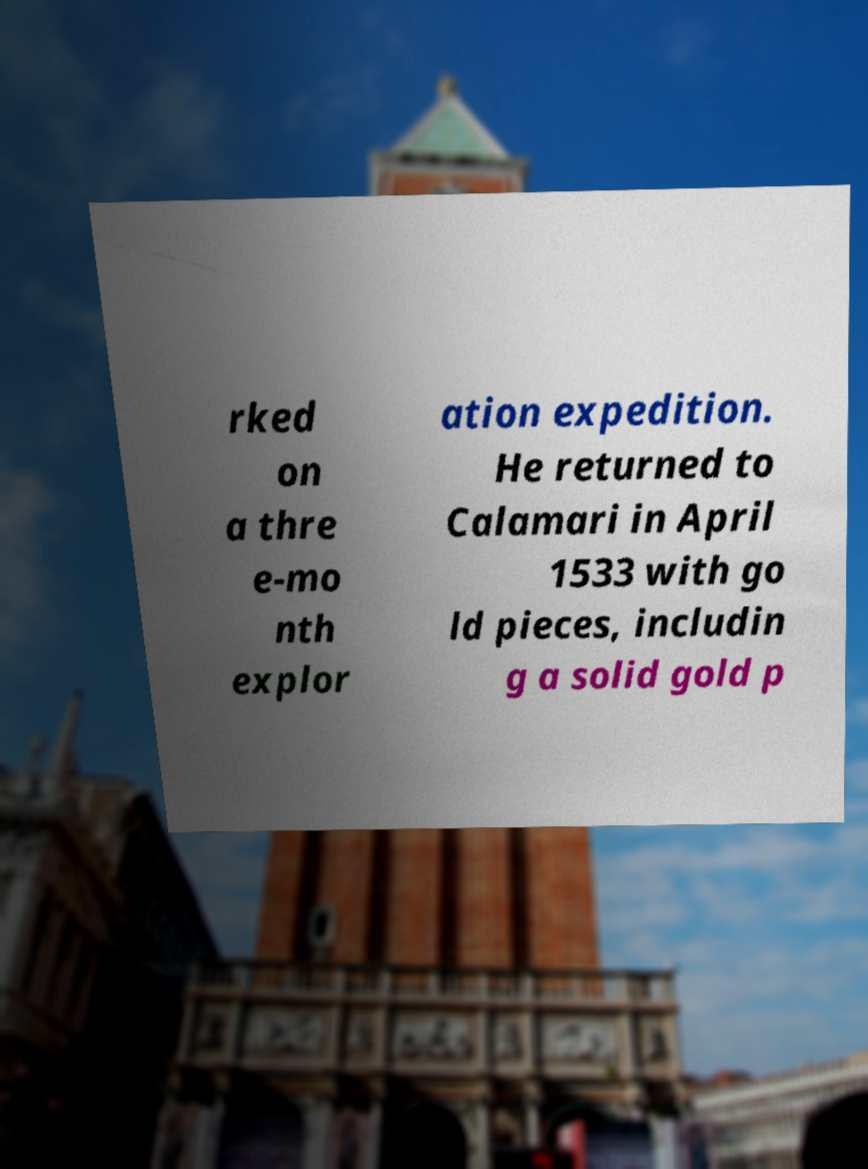Could you extract and type out the text from this image? rked on a thre e-mo nth explor ation expedition. He returned to Calamari in April 1533 with go ld pieces, includin g a solid gold p 